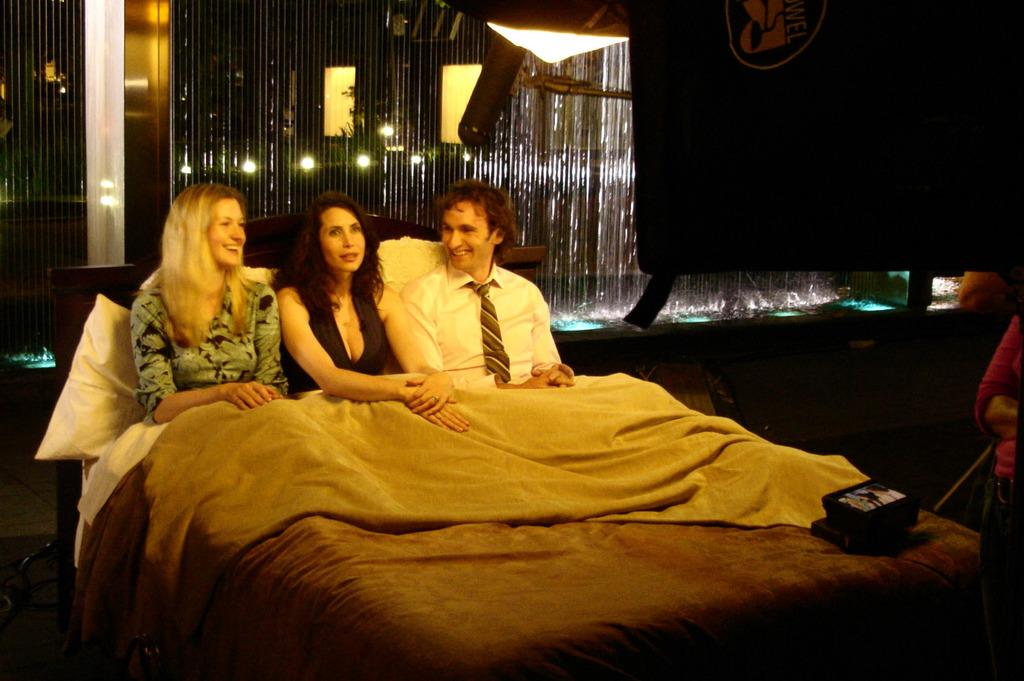How many people are in the image? There are three persons in the image. What are the persons doing in the image? The persons are sitting on a bed. What is covering their legs? There is a blanket over their legs. What other objects can be seen in the image? There is a box and a light in the image. What type of vegetable is growing in the hole in the image? There is no vegetable or hole present in the image. Can you describe the deer that is standing next to the persons in the image? There is no deer present in the image; it only features three persons sitting on a bed. 